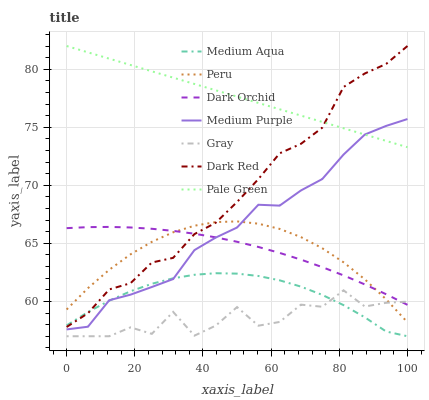Does Gray have the minimum area under the curve?
Answer yes or no. Yes. Does Pale Green have the maximum area under the curve?
Answer yes or no. Yes. Does Dark Red have the minimum area under the curve?
Answer yes or no. No. Does Dark Red have the maximum area under the curve?
Answer yes or no. No. Is Pale Green the smoothest?
Answer yes or no. Yes. Is Gray the roughest?
Answer yes or no. Yes. Is Dark Red the smoothest?
Answer yes or no. No. Is Dark Red the roughest?
Answer yes or no. No. Does Gray have the lowest value?
Answer yes or no. Yes. Does Dark Red have the lowest value?
Answer yes or no. No. Does Pale Green have the highest value?
Answer yes or no. Yes. Does Dark Orchid have the highest value?
Answer yes or no. No. Is Medium Aqua less than Pale Green?
Answer yes or no. Yes. Is Medium Purple greater than Gray?
Answer yes or no. Yes. Does Dark Orchid intersect Dark Red?
Answer yes or no. Yes. Is Dark Orchid less than Dark Red?
Answer yes or no. No. Is Dark Orchid greater than Dark Red?
Answer yes or no. No. Does Medium Aqua intersect Pale Green?
Answer yes or no. No. 